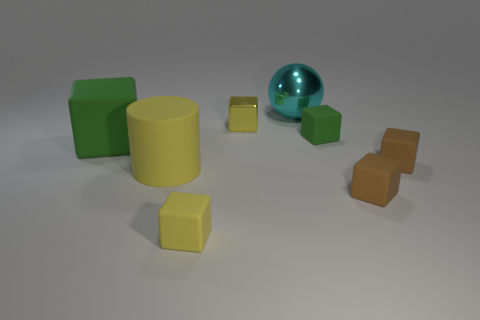Subtract 2 blocks. How many blocks are left? 4 Subtract all green cubes. How many cubes are left? 4 Subtract all yellow rubber blocks. How many blocks are left? 5 Subtract all red blocks. Subtract all yellow spheres. How many blocks are left? 6 Add 2 large cylinders. How many objects exist? 10 Subtract all cylinders. How many objects are left? 7 Add 7 green blocks. How many green blocks exist? 9 Subtract 2 yellow blocks. How many objects are left? 6 Subtract all yellow shiny cylinders. Subtract all large cyan things. How many objects are left? 7 Add 6 metallic cubes. How many metallic cubes are left? 7 